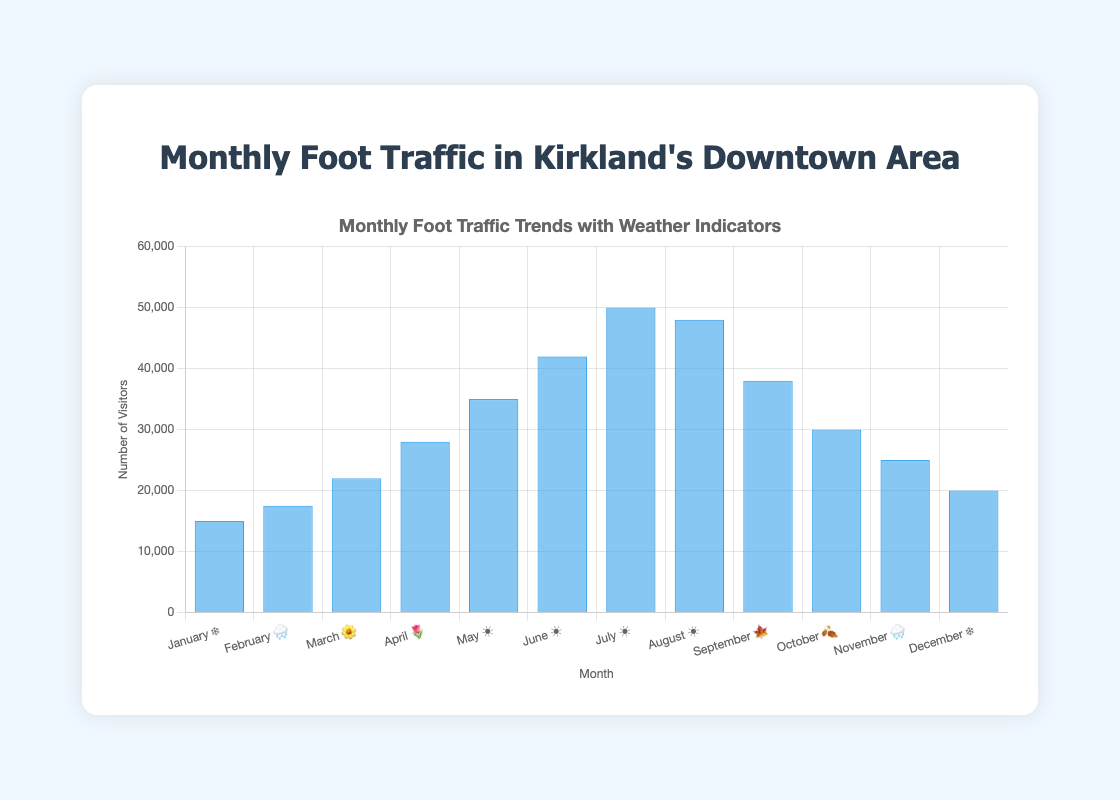What is the title of the figure? The title is located at the top center of the figure and typically summarizes the data presented. In this case, it reads "Monthly Foot Traffic Trends with Weather Indicators".
Answer: Monthly Foot Traffic Trends with Weather Indicators What month had the highest foot traffic? To find this, look for the tallest bar in the bar chart, which represents the month with the highest foot traffic. For this chart, July has the tallest bar with 50,000 visitors.
Answer: July What is the foot traffic in February compared to October? Locate the bars for February and October and compare their heights. February has 17,500 visitors, while October has 30,000 visitors. Subtract February's number from October's to find the difference.
Answer: February: 17,500, October: 30,000 What is the trend in foot traffic from June to August? Examine the bars for June, July, and August. June has 42,000, July has 50,000, and August has 48,000. The trend shows an increase from June to July and a slight decrease from July to August.
Answer: Increase then slight decrease How does the foot traffic in December compare to the foot traffic in January? Compare the height of the bars for December and January. December has 20,000 visitors, while January has 15,000 visitors.
Answer: December is higher What is the average foot traffic from May to August? Add the foot traffic numbers for May (35,000), June (42,000), July (50,000), and August (48,000), then divide by 4. (35,000 + 42,000 + 50,000 + 48,000) / 4 = 43,750.
Answer: 43,750 Which months have a foot traffic greater than 30,000? Identify the bars that surpass the 30,000 mark. The months are May, June, July, August, and September.
Answer: May, June, July, August, September What season displays the highest foot traffic? Consider the months and their respective seasons. Summer (June, July, August) displays the highest foot traffic with consistently high values.
Answer: Summer How does the weather emoji correspond to foot traffic trends? Observe the correlation between the weather emojis and foot traffic. For instance, sunny months (☀️) tend to have higher foot traffic, while snowy (❄️) and rainy (🌧️) months have lower traffic.
Answer: Sunny months higher, snowy/rainy months lower 